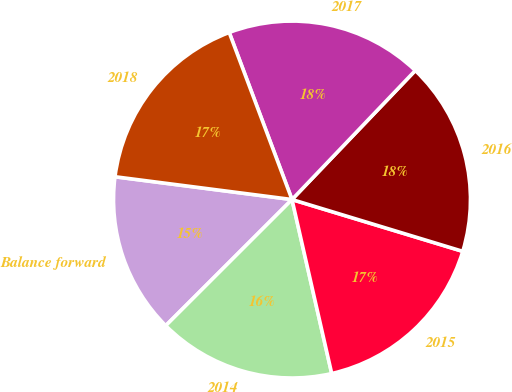Convert chart to OTSL. <chart><loc_0><loc_0><loc_500><loc_500><pie_chart><fcel>Balance forward<fcel>2014<fcel>2015<fcel>2016<fcel>2017<fcel>2018<nl><fcel>14.53%<fcel>16.08%<fcel>16.74%<fcel>17.55%<fcel>17.86%<fcel>17.24%<nl></chart> 